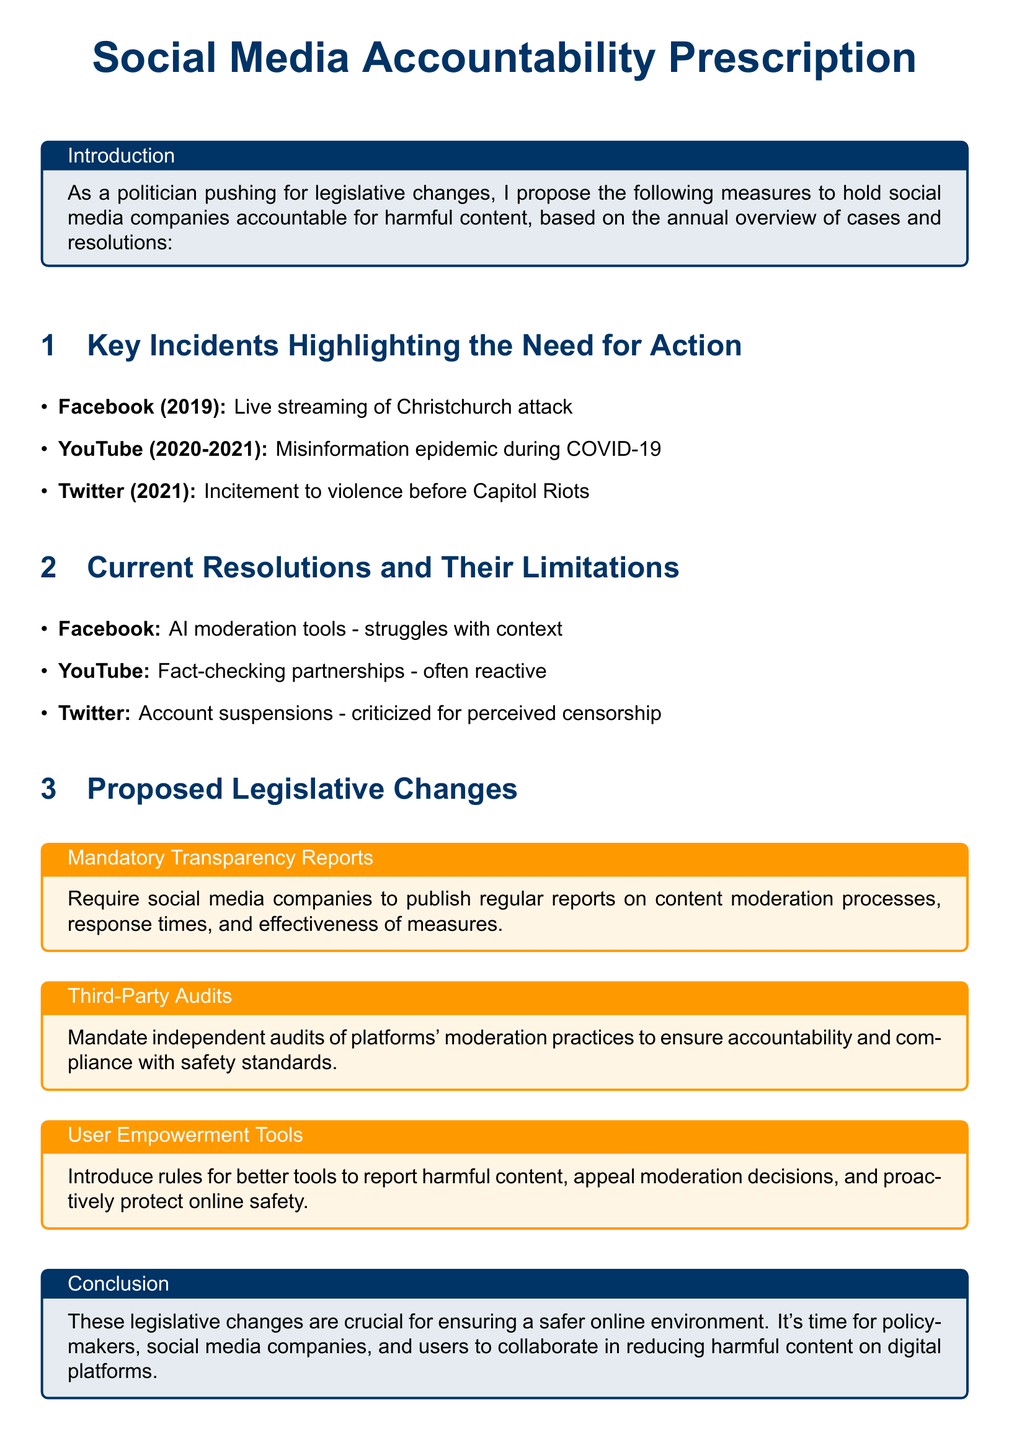What was the incident involving Facebook in 2019? The incident highlighted is the live streaming of the Christchurch attack.
Answer: live streaming of Christchurch attack What misinformation epidemic occurred during which years on YouTube? The document states that the misinformation epidemic occurred during COVID-19, which spans 2020 to 2021.
Answer: 2020-2021 What moderation tool does Facebook use? The document mentions AI moderation tools used by Facebook.
Answer: AI moderation tools What type of audits are proposed in the legislative changes? The proposed audits are independent audits of platforms' moderation practices.
Answer: independent audits What is a proposed legislative change aimed at user protection? The document suggests introducing better tools for reporting harmful content.
Answer: user empowerment tools How has Twitter's account suspension been viewed? The document notes that Twitter's account suspensions have been criticized for perceived censorship.
Answer: perceived censorship What is required from social media companies in the 'Mandatory Transparency Reports'? The requirement is to publish regular reports on content moderation processes.
Answer: content moderation processes What was a key incident involving Twitter in 2021? The key incident was the incitement to violence before the Capitol Riots.
Answer: incitement to violence before Capitol Riots What is the overall goal of the proposed legislative changes? The goal is to ensure a safer online environment.
Answer: safer online environment 